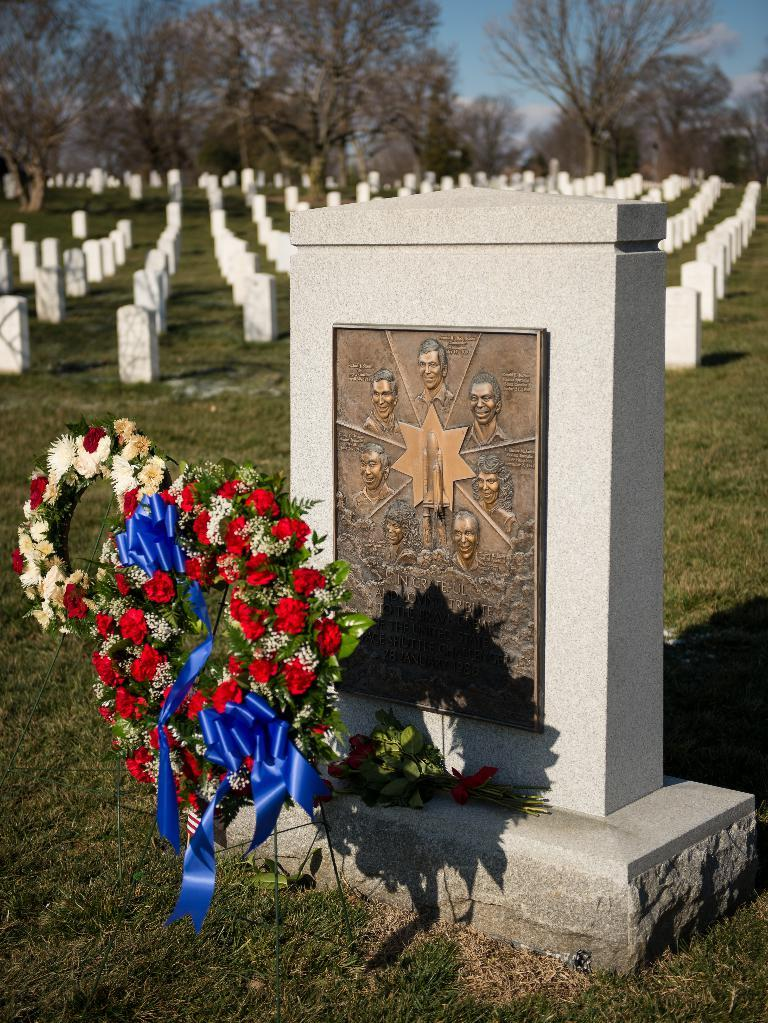What type of location is depicted in the image? The image contains graveyards. What type of vegetation can be seen in the image? There is grass and flowers visible in the image. What can be seen in the background of the image? There are trees in the background of the image. What is visible at the top of the image? The sky is visible at the top of the image. Can you describe the waves in the image? There are no waves present in the image; it features graveyards, grass, flowers, trees, and the sky. What type of transport is visible in the image? There is no transport present in the image. 